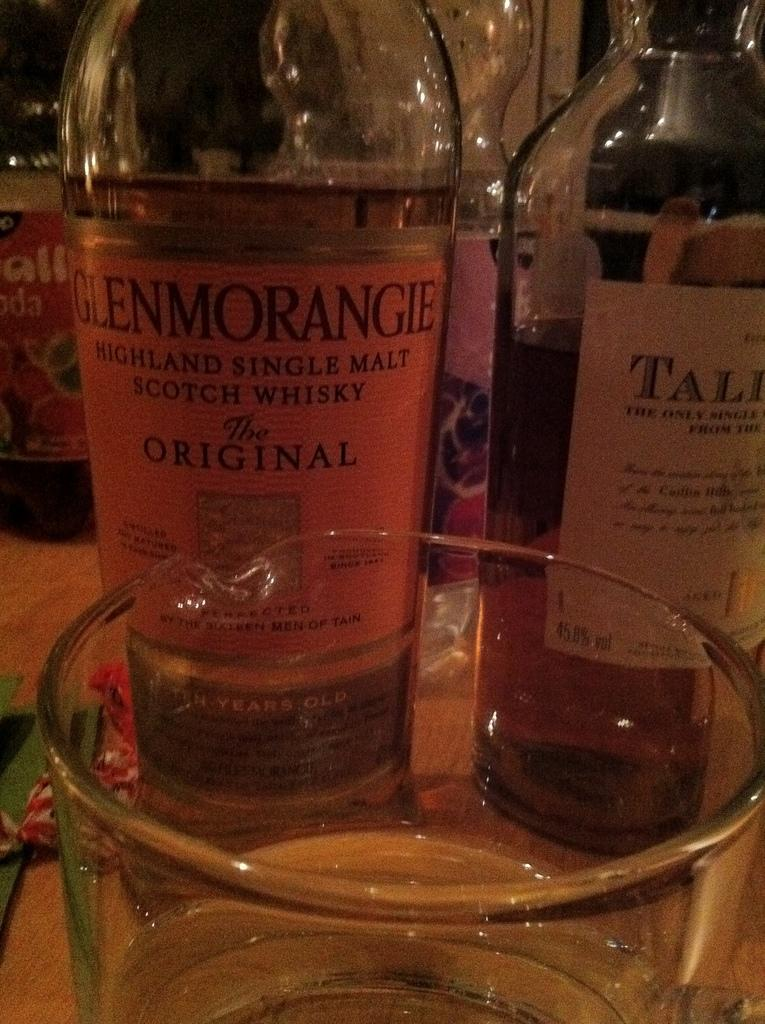Provide a one-sentence caption for the provided image. Glass filled with malt liquor on a table with malt liquor bottles. 